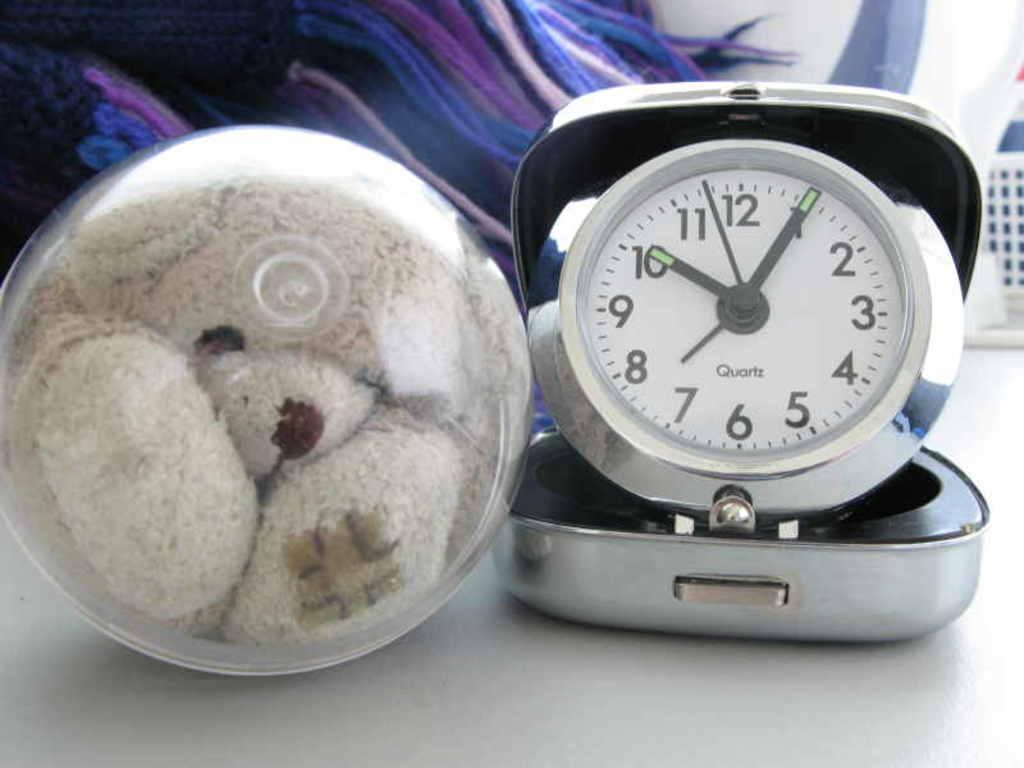<image>
Describe the image concisely. A teddy bear next to a clock that reads 10:05. 